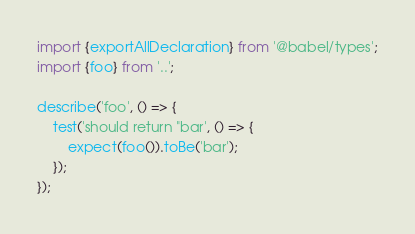Convert code to text. <code><loc_0><loc_0><loc_500><loc_500><_TypeScript_>import {exportAllDeclaration} from '@babel/types';
import {foo} from '..';

describe('foo', () => {
	test('should return "bar', () => {
		expect(foo()).toBe('bar');
	});
});
</code> 